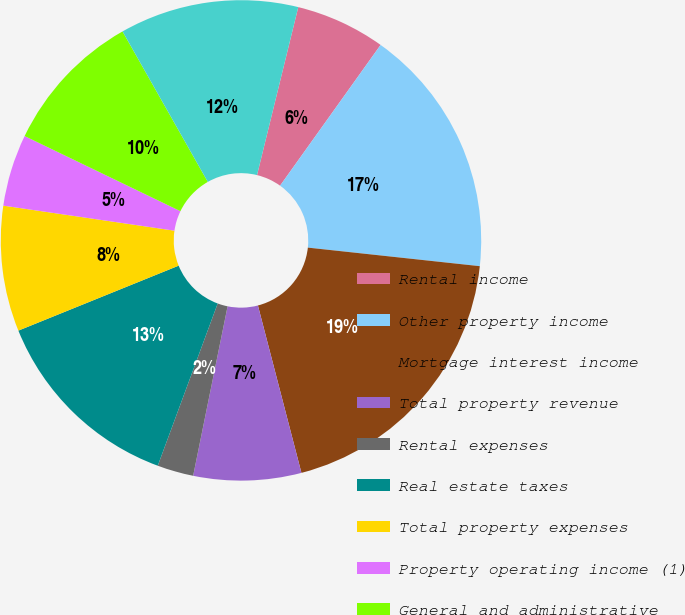Convert chart. <chart><loc_0><loc_0><loc_500><loc_500><pie_chart><fcel>Rental income<fcel>Other property income<fcel>Mortgage interest income<fcel>Total property revenue<fcel>Rental expenses<fcel>Real estate taxes<fcel>Total property expenses<fcel>Property operating income (1)<fcel>General and administrative<fcel>Depreciation and amortization<nl><fcel>6.04%<fcel>16.84%<fcel>19.24%<fcel>7.24%<fcel>2.44%<fcel>13.24%<fcel>8.44%<fcel>4.84%<fcel>9.64%<fcel>12.04%<nl></chart> 